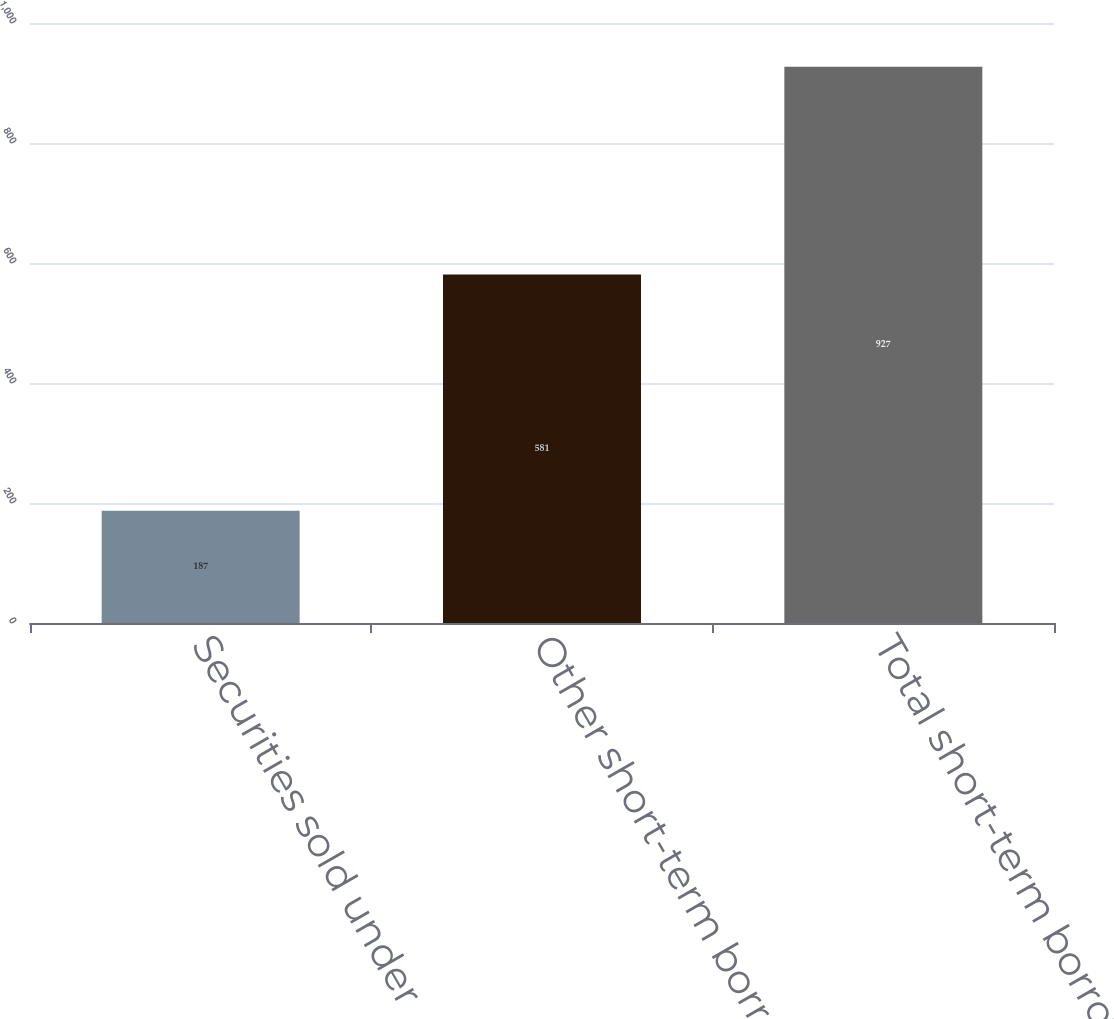Convert chart. <chart><loc_0><loc_0><loc_500><loc_500><bar_chart><fcel>Securities sold under<fcel>Other short-term borrowed<fcel>Total short-term borrowed<nl><fcel>187<fcel>581<fcel>927<nl></chart> 